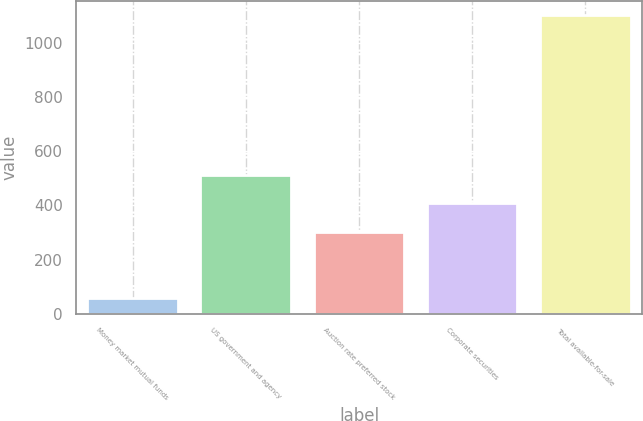Convert chart to OTSL. <chart><loc_0><loc_0><loc_500><loc_500><bar_chart><fcel>Money market mutual funds<fcel>US government and agency<fcel>Auction rate preferred stock<fcel>Corporate securities<fcel>Total available-for-sale<nl><fcel>60<fcel>512<fcel>304<fcel>408<fcel>1100<nl></chart> 